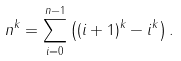<formula> <loc_0><loc_0><loc_500><loc_500>n ^ { k } = \sum _ { i = 0 } ^ { n - 1 } \left ( ( i + 1 ) ^ { k } - i ^ { k } \right ) .</formula> 